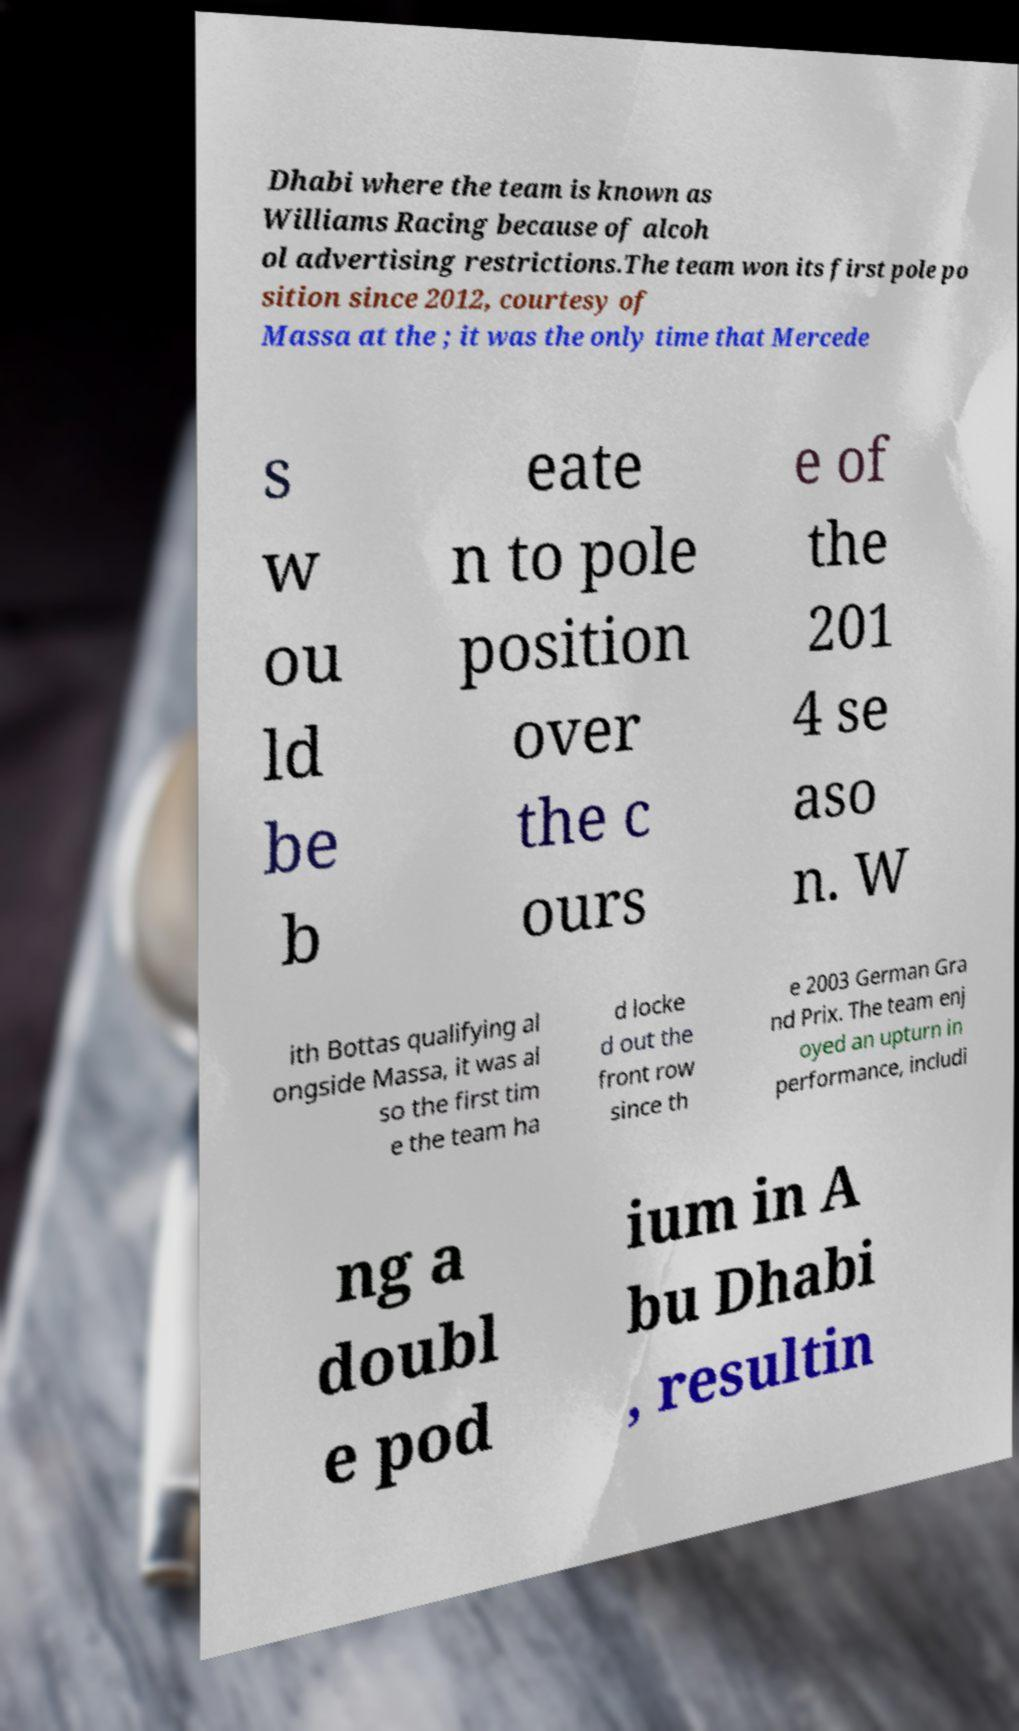Can you read and provide the text displayed in the image?This photo seems to have some interesting text. Can you extract and type it out for me? Dhabi where the team is known as Williams Racing because of alcoh ol advertising restrictions.The team won its first pole po sition since 2012, courtesy of Massa at the ; it was the only time that Mercede s w ou ld be b eate n to pole position over the c ours e of the 201 4 se aso n. W ith Bottas qualifying al ongside Massa, it was al so the first tim e the team ha d locke d out the front row since th e 2003 German Gra nd Prix. The team enj oyed an upturn in performance, includi ng a doubl e pod ium in A bu Dhabi , resultin 